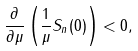<formula> <loc_0><loc_0><loc_500><loc_500>\frac { \partial } { \partial \mu } \left ( \frac { 1 } { \mu } S _ { n } ( 0 ) \right ) < 0 ,</formula> 